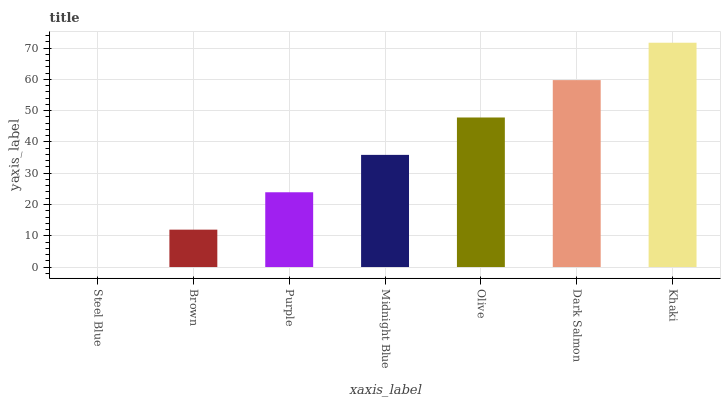Is Brown the minimum?
Answer yes or no. No. Is Brown the maximum?
Answer yes or no. No. Is Brown greater than Steel Blue?
Answer yes or no. Yes. Is Steel Blue less than Brown?
Answer yes or no. Yes. Is Steel Blue greater than Brown?
Answer yes or no. No. Is Brown less than Steel Blue?
Answer yes or no. No. Is Midnight Blue the high median?
Answer yes or no. Yes. Is Midnight Blue the low median?
Answer yes or no. Yes. Is Purple the high median?
Answer yes or no. No. Is Brown the low median?
Answer yes or no. No. 